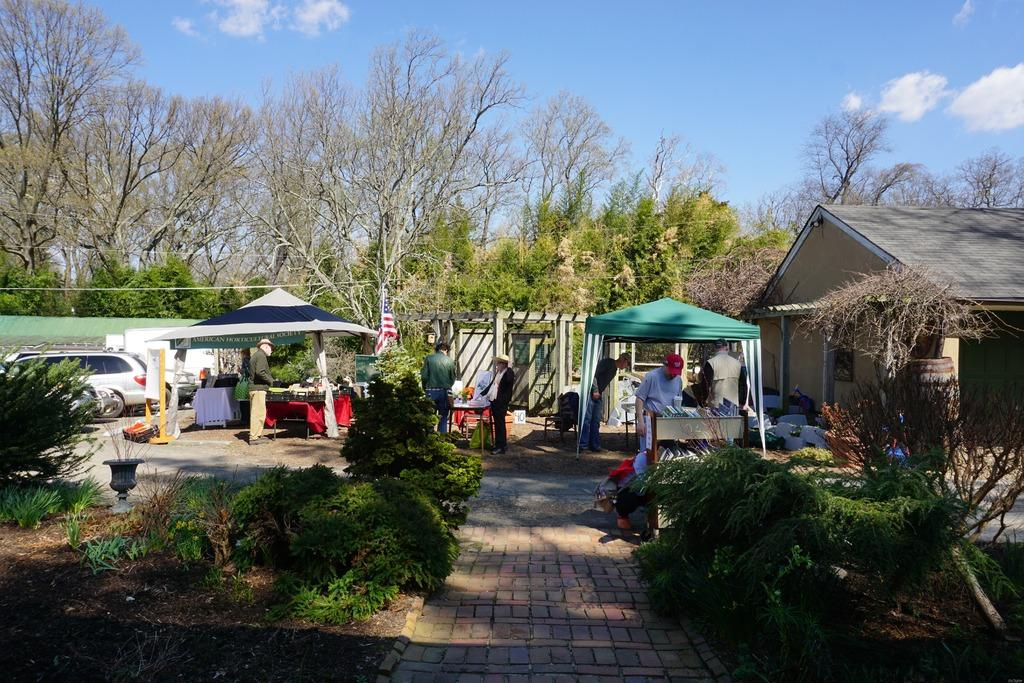What are the people in the image doing? The people in the image are standing on the ground. What structures can be seen in the image? There are tents, vehicles, a house, and a flag in the image. What type of vegetation is present in the image? There are trees in the image. What is visible in the background of the image? The sky with clouds is visible in the background of the image. How many tomatoes are stored in the drawer in the image? There is no drawer or tomatoes present in the image. What day of the week is it in the image? The day of the week is not mentioned or visible in the image. 